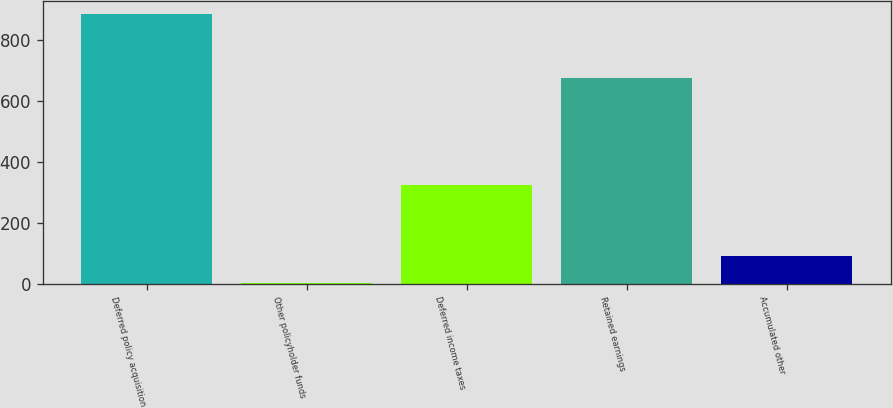Convert chart. <chart><loc_0><loc_0><loc_500><loc_500><bar_chart><fcel>Deferred policy acquisition<fcel>Other policyholder funds<fcel>Deferred income taxes<fcel>Retained earnings<fcel>Accumulated other<nl><fcel>885.5<fcel>4.9<fcel>324.7<fcel>675.2<fcel>92.96<nl></chart> 